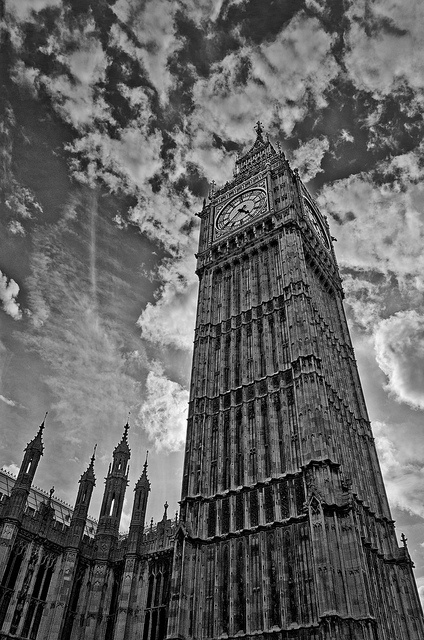Describe the objects in this image and their specific colors. I can see clock in black, darkgray, gray, and lightgray tones and clock in black, gray, darkgray, and lightgray tones in this image. 